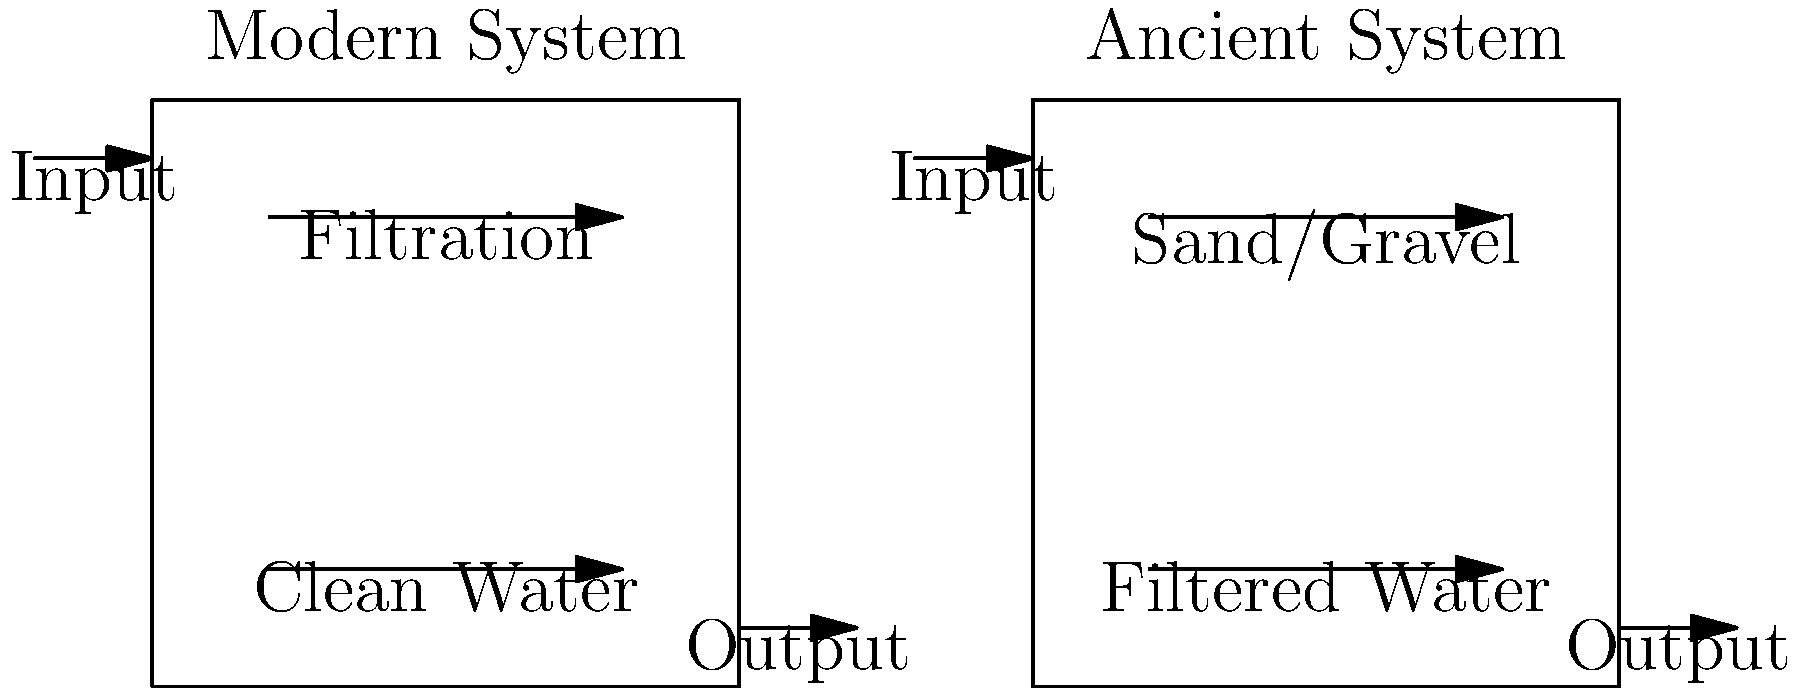As a documentary filmmaker collaborating with an anthropologist, you're creating a visual comparison of modern and ancient water filtration systems. Based on the schematic, what key difference can you identify between the two systems that would be crucial to highlight in your documentary? To answer this question, let's analyze the schematic step-by-step:

1. Modern System:
   - Shows a single-stage filtration process
   - Input water goes through a "Filtration" stage
   - Output is labeled as "Clean Water"

2. Ancient System:
   - Also shows a single-stage filtration process
   - Input water goes through a "Sand/Gravel" stage
   - Output is labeled as "Filtered Water"

3. Key differences:
   a) Filtration medium:
      - Modern system: Unspecified "Filtration" (implying advanced techniques)
      - Ancient system: Specifically mentions "Sand/Gravel"
   
   b) Output labeling:
      - Modern system: "Clean Water"
      - Ancient system: "Filtered Water"

4. Crucial point for the documentary:
   The key difference to highlight is the filtration medium and its implications. The ancient system uses natural materials (sand and gravel), while the modern system likely employs more advanced filtration techniques (e.g., chemical treatment, UV disinfection, or membrane filtration).

5. Impact on water quality:
   The labeling of the output ("Clean Water" vs. "Filtered Water") suggests that the modern system might produce water of higher quality or with more contaminants removed.

This comparison would be crucial to highlight in the documentary as it demonstrates the evolution of water treatment technology and its impact on water quality.
Answer: Filtration medium: natural (ancient) vs. advanced (modern) 